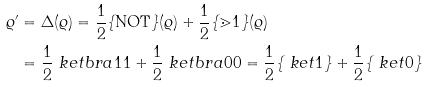<formula> <loc_0><loc_0><loc_500><loc_500>\varrho ^ { \prime } & = \Delta ( \varrho ) = \frac { 1 } { 2 } \{ \text {NOT} \} ( \varrho ) + \frac { 1 } { 2 } \{ \mathbb { m } { 1 } \} ( \varrho ) \\ & = \frac { 1 } { 2 } \ k e t b r a { 1 } { 1 } + \frac { 1 } { 2 } \ k e t b r a { 0 } { 0 } = \frac { 1 } { 2 } \{ \ k e t { 1 } \} + \frac { 1 } { 2 } \{ \ k e t { 0 } \}</formula> 